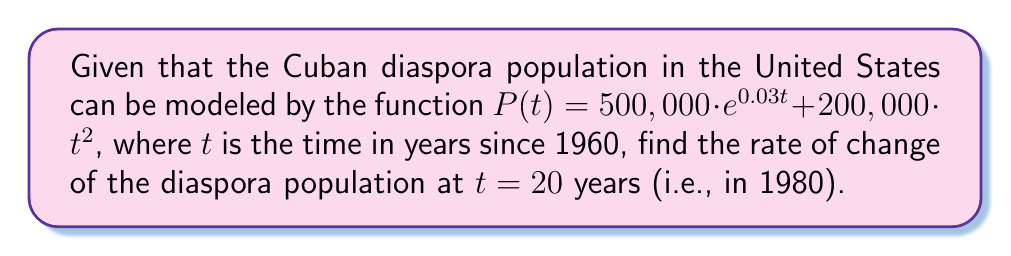Give your solution to this math problem. To find the rate of change of the Cuban diaspora population at $t = 20$, we need to find the derivative of the given function $P(t)$ and then evaluate it at $t = 20$.

Let's break this down step-by-step:

1) The given function is $P(t) = 500,000 \cdot e^{0.03t} + 200,000 \cdot t^2$

2) To find the derivative, we'll use the sum rule and apply the chain rule for the exponential term:

   $$\frac{d}{dt}[P(t)] = \frac{d}{dt}[500,000 \cdot e^{0.03t}] + \frac{d}{dt}[200,000 \cdot t^2]$$

3) For the exponential term:
   $$\frac{d}{dt}[500,000 \cdot e^{0.03t}] = 500,000 \cdot 0.03 \cdot e^{0.03t} = 15,000 \cdot e^{0.03t}$$

4) For the quadratic term:
   $$\frac{d}{dt}[200,000 \cdot t^2] = 200,000 \cdot 2t = 400,000t$$

5) Combining these results:
   $$P'(t) = 15,000 \cdot e^{0.03t} + 400,000t$$

6) Now, we evaluate this at $t = 20$:
   $$P'(20) = 15,000 \cdot e^{0.03 \cdot 20} + 400,000 \cdot 20$$
   $$= 15,000 \cdot e^{0.6} + 8,000,000$$
   $$\approx 15,000 \cdot 1.8221 + 8,000,000$$
   $$\approx 27,331.5 + 8,000,000$$
   $$\approx 8,027,331.5$$

This result represents the rate of change of the Cuban diaspora population in 1980, measured in people per year.
Answer: The rate of change of the Cuban diaspora population in 1980 (20 years after 1960) was approximately 8,027,332 people per year. 